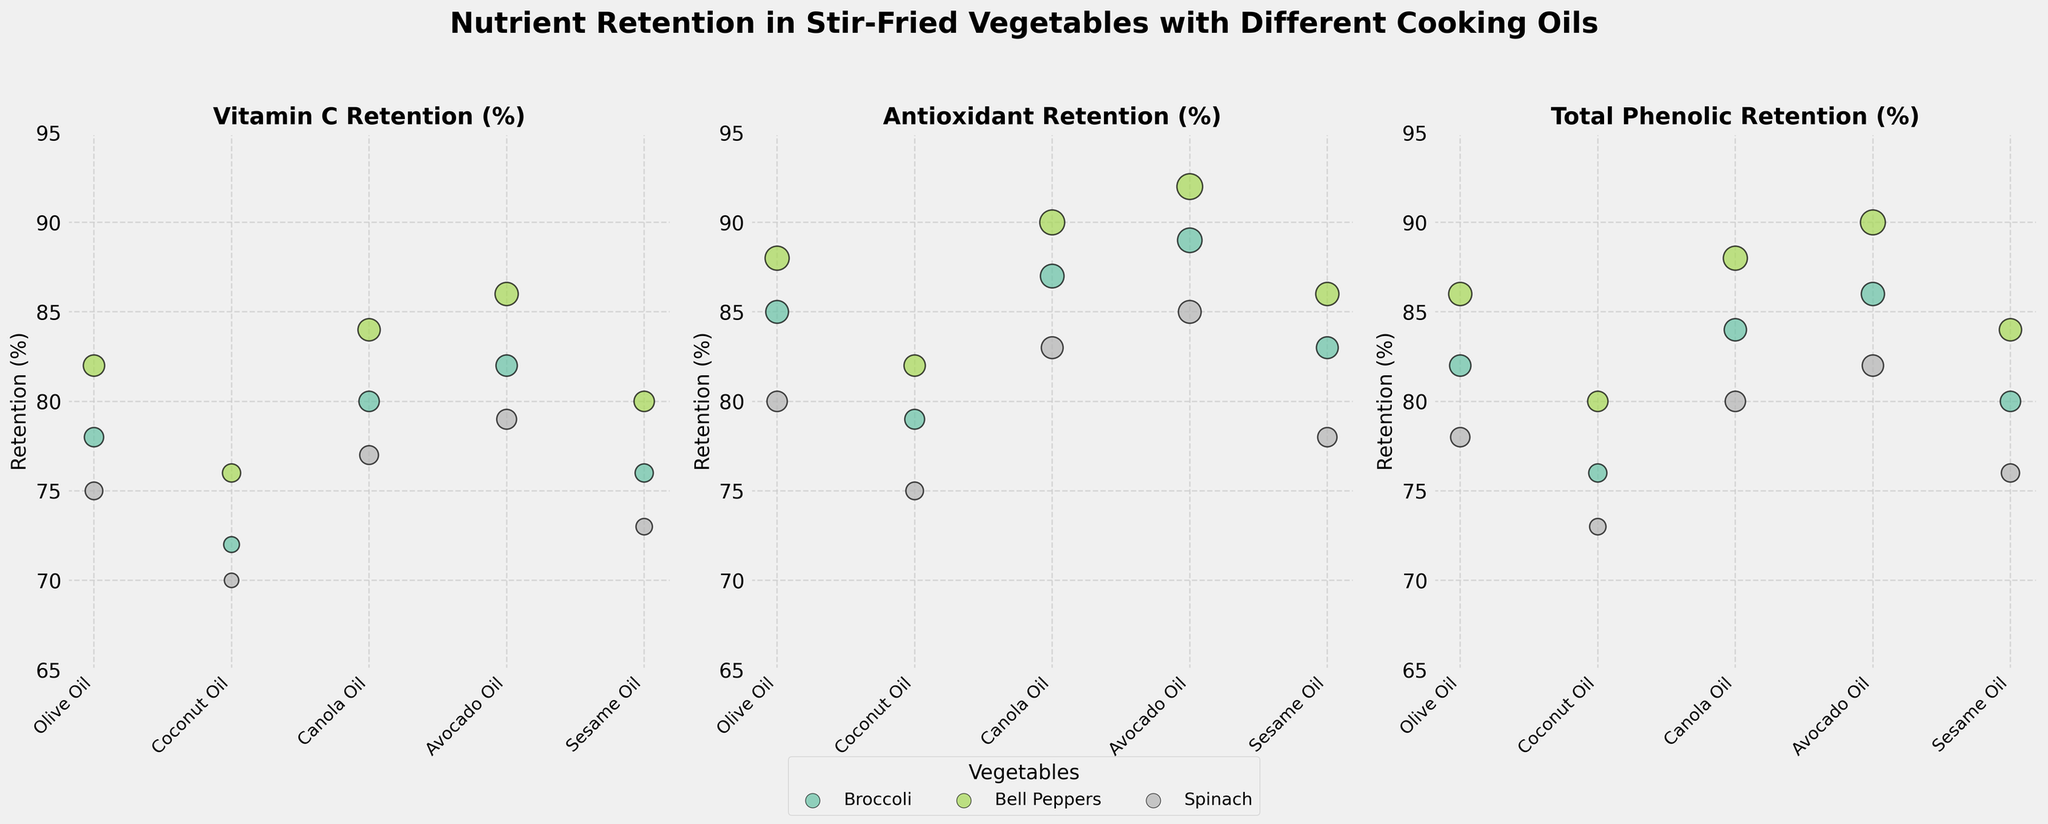What is the title of the figure? Look at the top of the figure to find the title in bold font.
Answer: Nutrient Retention in Stir-Fried Vegetables with Different Cooking Oils Which cooking oil results in the highest Vitamin C retention in Bell Peppers? Refer to the subplot for Vitamin C retention and look for the highest bubble corresponding to Bell Peppers' color near the tick labeled Bell Peppers on the x-axis.
Answer: Avocado Oil How many vegetables are represented in the figure? Examine the legend of the figure, which labels the data points by vegetable type. There are five different colors, each representing a distinct vegetable.
Answer: 3 What is the average Total Phenolic Retention (%) for Spinach across all cooking oils? Look at the Total Phenolic Retention subplot and locate the bubbles representing Spinach (according to its color in the legend) for all oils, then calculate their average: (78 + 73 + 80 + 82 + 76) / 5.
Answer: 77.8% Which oil shows the lowest Antioxidant Retention (%) across all vegetables? Compare the lowest points in the Antioxidant Retention subplot, corresponding to all oils, and find the lowest value across them.
Answer: Coconut Oil Are there any vegetables that maintain their nutrient retention nearly the same across all cooking oils? Compare the size and vertical position of the bubbles for each vegetable across different subplots to see if any vegetable has similar retention percentages for each nutrient across all oils.
Answer: No What is the average Vitamin C Retention (%) for Olive Oil across all vegetables? Locate the bubbles for Olive Oil in the Vitamin C Retention subplot and average their values: (78 + 82 + 75) / 3.
Answer: 78.33% Compare the Total Phenolic Retention (%) between Avocado Oil and Canola Oil for Broccoli. Which has higher retention? Check the subpoints of Total Phenolic Retention (%) for Broccoli for both oils, then compare their bubble heights.
Answer: Avocado Oil Which vegetable shows the highest Total Phenolic Retention (%) with Canola Oil? Check the Total Phenolic Retention (%) subplot and compare the colored bubbles for Canola Oil. Look for the highest bubble among them.
Answer: Bell Peppers What is the difference in Antioxidant Retention (%) between Olive Oil and Sesame Oil for Bell Peppers? Locate the Bell Peppers' colored bubbles for both Olive Oil and Sesame Oil in the Antioxidant Retention subplot, then subtract the value for Sesame Oil from that of Olive Oil (88 - 86).
Answer: 2% 